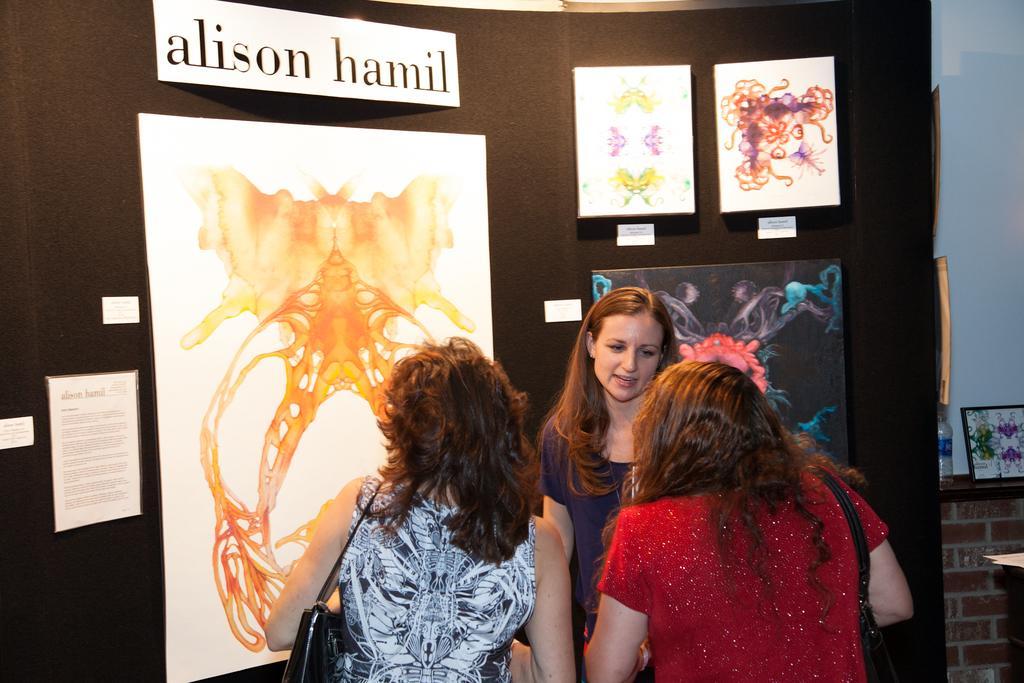Could you give a brief overview of what you see in this image? In this image there are three girls standing, in front of them there are paintings, poster and labels on it, beside that there is a frame and a bottle on the platform and there is a wall. 